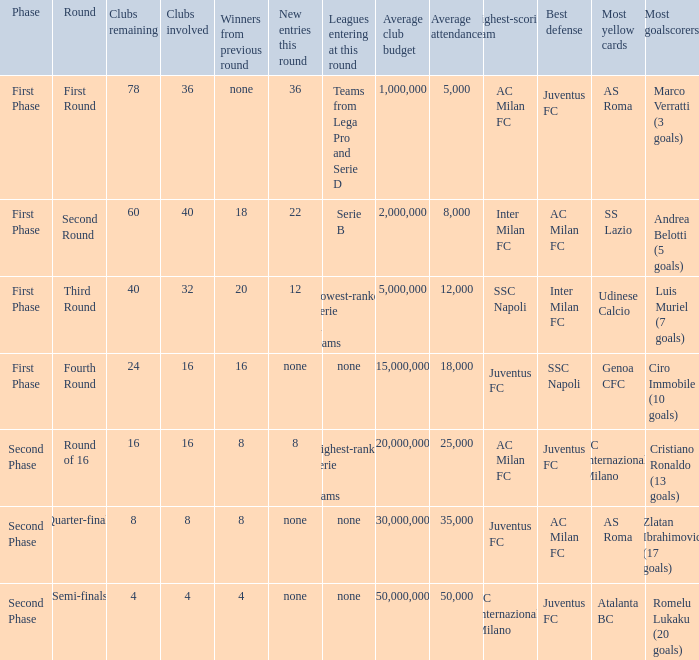From the round name of third round; what would the new entries this round that would be found? 12.0. 